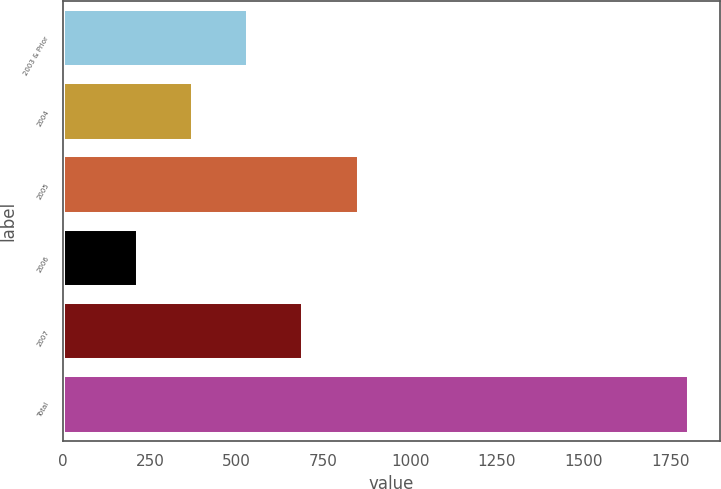Convert chart. <chart><loc_0><loc_0><loc_500><loc_500><bar_chart><fcel>2003 & Prior<fcel>2004<fcel>2005<fcel>2006<fcel>2007<fcel>Total<nl><fcel>534<fcel>375.35<fcel>851.3<fcel>216.7<fcel>692.65<fcel>1803.2<nl></chart> 